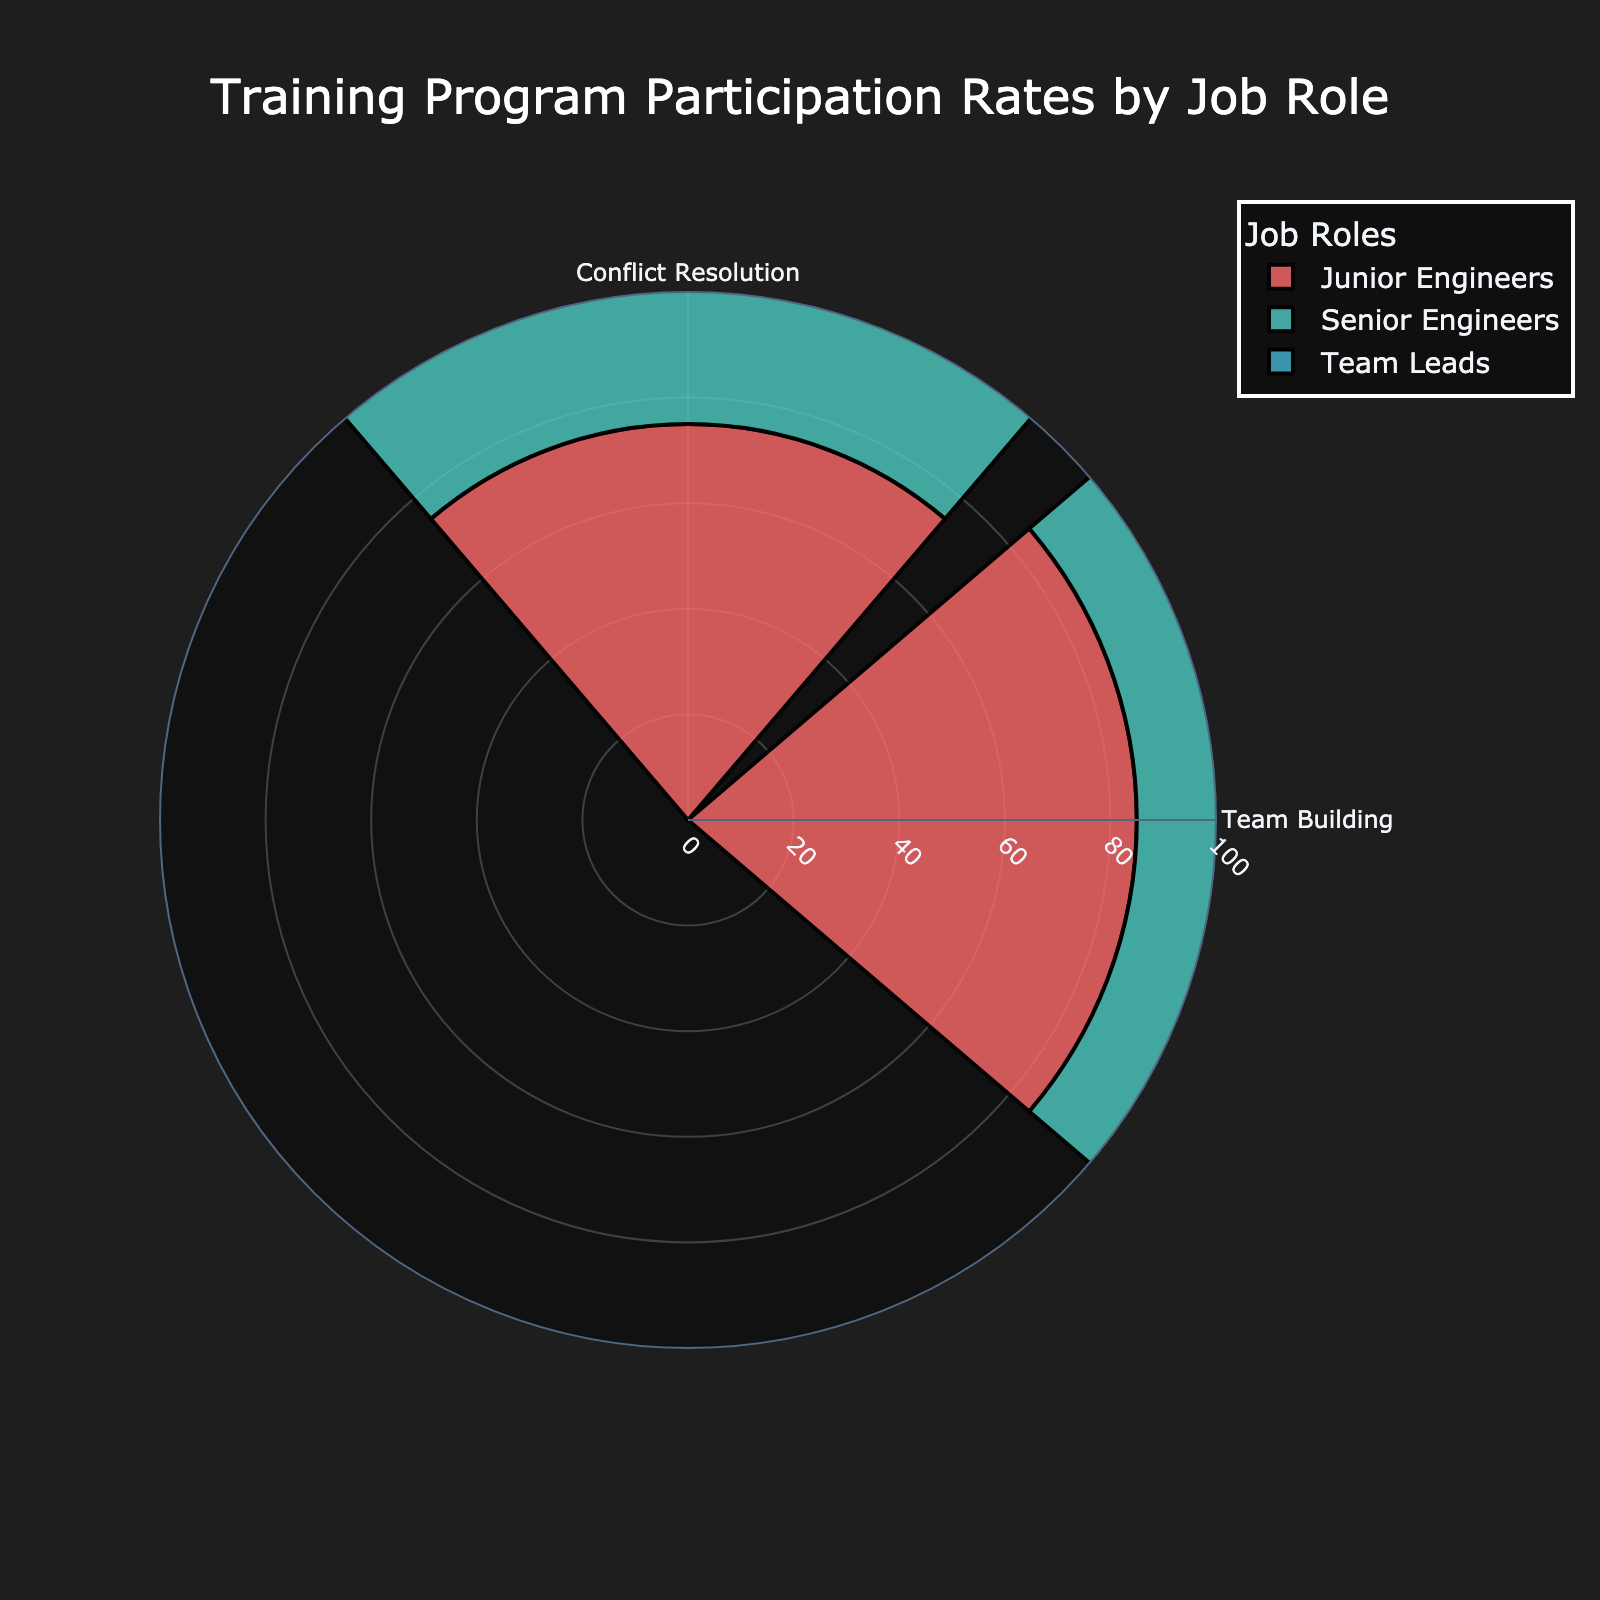What is the title of the chart? The chart title is typically displayed prominently above the main visual part of the figure, helping viewers quickly understand the topic. In this case, the title helps viewers know the purpose of the chart.
Answer: Training Program Participation Rates by Job Role Which job role has the highest participation rate for the Team Building program? To answer this question, look at the bars associated with the Team Building program and compare the participation rates for each job role. The bar with the highest value will indicate the job role with the highest participation rate.
Answer: Team Leads For the Conflict Resolution program, which job role has the lowest participation rate? Inspect the bars corresponding to the Conflict Resolution program and identify the smallest bar among the job roles. This bar indicates the job role with the lowest participation rate.
Answer: Senior Engineers What is the participation rate range for the Team Building program across all job roles? To determine the range, identify the highest and lowest participation rates for the Team Building program and subtract the lowest value from the highest value. The difference between these values gives the range. The Senior Engineers have a 90% rate, the Junior Engineers 85%, and the Team Leads 95%. The range is therefore 95% - 85% = 10%.
Answer: 10% How does the participation rate in Conflict Resolution for Junior Engineers compare to that for Team Leads? Look at the bars associated with Conflict Resolution for both Junior Engineers and Team Leads. Compare their heights to see which is higher and by how much. Junior Engineers have a rate of 75%, and Team Leads have a rate of 80%.
Answer: Team Leads have a higher participation rate by 5% What is the average participation rate for Junior Engineers across both programs? To find this, sum the participation rates for Junior Engineers in the Conflict Resolution and Team Building programs and divide by the number of programs (which is 2). The rates are 75% and 85%, so (75 + 85) / 2 = 80%.
Answer: 80% Which program has the highest participation rate among all job roles? Examine the bars for both the Conflict Resolution and Team Building programs across all job roles. Identify the program with the highest single participation rate among all the job roles. The highest rate is for Team Leads in the Team Building program at 95%.
Answer: Team Building By how much does the participation rate in Team Building for Senior Engineers exceed their participation rate in Conflict Resolution? Subtract the participation rate for Conflict Resolution from the participation rate for Team Building for Senior Engineers. The rates are 90% and 65%, so 90% - 65% = 25%.
Answer: 25% What's the ratio of participation rates between Junior Engineers and Senior Engineers for the Team Building program? Divide the participation rate of Junior Engineers by that of Senior Engineers for the Team Building program. The rates are 85% and 90%, so the ratio is 85/90 = 0.94.
Answer: 0.94 